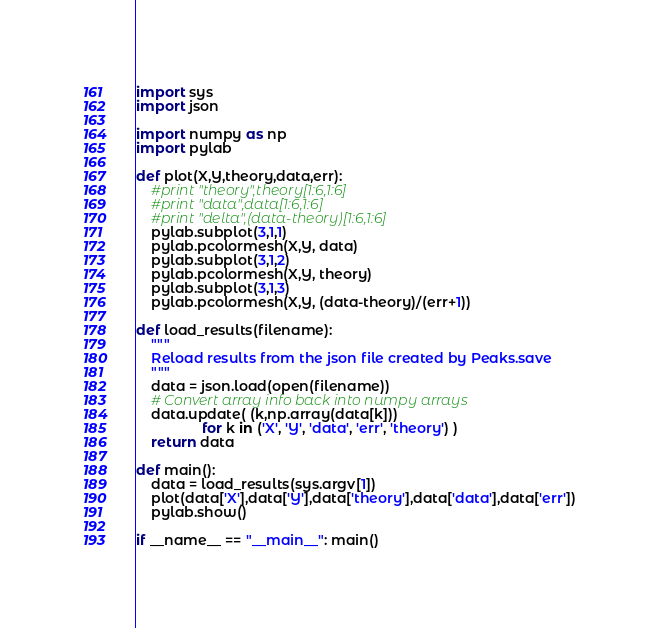Convert code to text. <code><loc_0><loc_0><loc_500><loc_500><_Python_>import sys
import json

import numpy as np
import pylab

def plot(X,Y,theory,data,err):
    #print "theory",theory[1:6,1:6]
    #print "data",data[1:6,1:6]
    #print "delta",(data-theory)[1:6,1:6]
    pylab.subplot(3,1,1)
    pylab.pcolormesh(X,Y, data)
    pylab.subplot(3,1,2)
    pylab.pcolormesh(X,Y, theory)
    pylab.subplot(3,1,3)
    pylab.pcolormesh(X,Y, (data-theory)/(err+1))

def load_results(filename):
    """
    Reload results from the json file created by Peaks.save
    """
    data = json.load(open(filename))
    # Convert array info back into numpy arrays
    data.update( (k,np.array(data[k]))
                 for k in ('X', 'Y', 'data', 'err', 'theory') )
    return data

def main():
    data = load_results(sys.argv[1])
    plot(data['X'],data['Y'],data['theory'],data['data'],data['err'])
    pylab.show()

if __name__ == "__main__": main()
</code> 